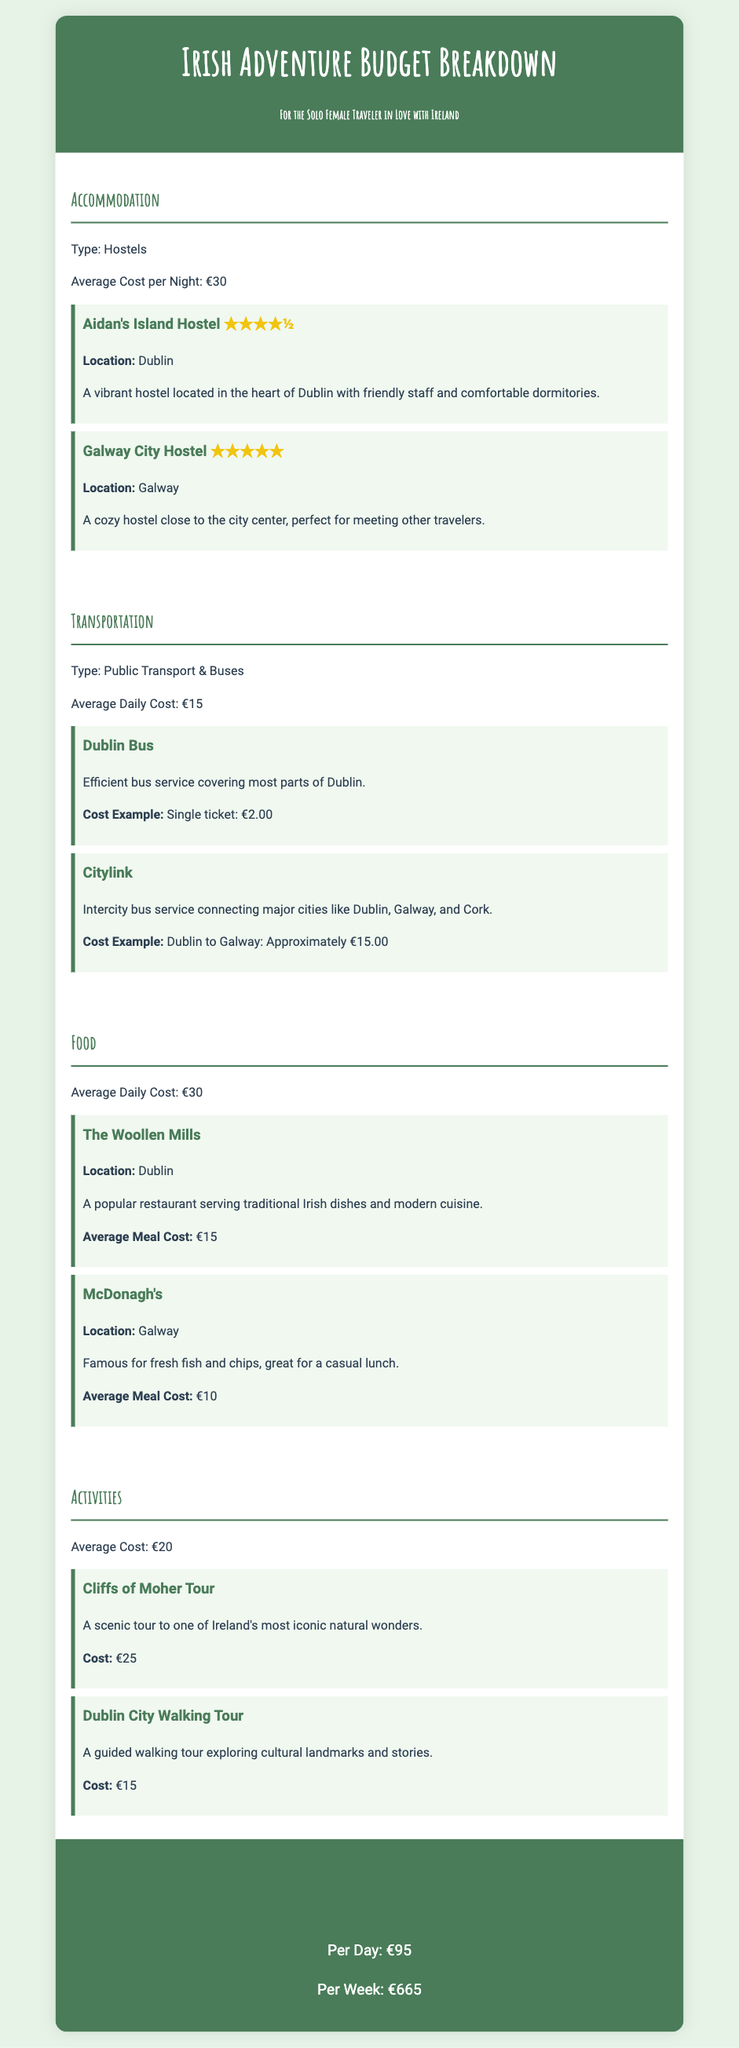What is the average cost per night for accommodation? The average cost per night for accommodation listed in the document is €30.
Answer: €30 What is the average daily cost for food? The document specifies that the average daily cost for food is €30.
Answer: €30 Which hostel in Galway has a five-star rating? The document highlights Galway City Hostel as having a five-star rating.
Answer: Galway City Hostel What is the cost for a Dublin to Galway bus ticket? The document provides the cost example for this ticket as approximately €15.00.
Answer: Approximately €15.00 What is the total estimated cost per week? The document mentions that the total estimated cost per week is €665.
Answer: €665 How much does the Cliffs of Moher Tour cost? The document states that the cost for the Cliffs of Moher Tour is €25.
Answer: €25 What city is The Woollen Mills located in? According to the document, The Woollen Mills is located in Dublin.
Answer: Dublin What type of transportation is primarily used? The document indicates that public transport and buses are the primary types of transportation used.
Answer: Public Transport & Buses What is the rating for Aidan's Island Hostel? The rating for Aidan's Island Hostel in the document is four and a half stars.
Answer: ★★★★½ 